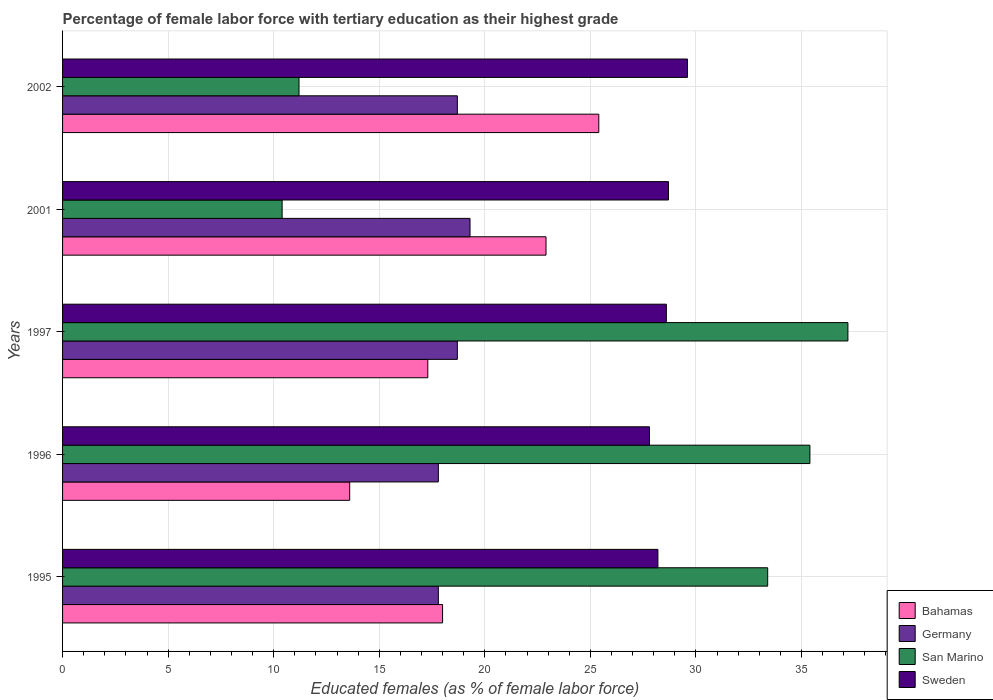How many different coloured bars are there?
Ensure brevity in your answer.  4. Are the number of bars per tick equal to the number of legend labels?
Offer a terse response. Yes. How many bars are there on the 3rd tick from the top?
Provide a short and direct response. 4. What is the percentage of female labor force with tertiary education in San Marino in 2001?
Make the answer very short. 10.4. Across all years, what is the maximum percentage of female labor force with tertiary education in Bahamas?
Provide a short and direct response. 25.4. Across all years, what is the minimum percentage of female labor force with tertiary education in Sweden?
Offer a very short reply. 27.8. In which year was the percentage of female labor force with tertiary education in San Marino minimum?
Offer a terse response. 2001. What is the total percentage of female labor force with tertiary education in Sweden in the graph?
Give a very brief answer. 142.9. What is the difference between the percentage of female labor force with tertiary education in Germany in 1995 and that in 2002?
Your answer should be compact. -0.9. What is the difference between the percentage of female labor force with tertiary education in San Marino in 1997 and the percentage of female labor force with tertiary education in Sweden in 2002?
Offer a terse response. 7.6. What is the average percentage of female labor force with tertiary education in Sweden per year?
Make the answer very short. 28.58. In the year 1997, what is the difference between the percentage of female labor force with tertiary education in Bahamas and percentage of female labor force with tertiary education in Germany?
Ensure brevity in your answer.  -1.4. What is the ratio of the percentage of female labor force with tertiary education in Sweden in 1996 to that in 2002?
Make the answer very short. 0.94. Is the difference between the percentage of female labor force with tertiary education in Bahamas in 1995 and 2002 greater than the difference between the percentage of female labor force with tertiary education in Germany in 1995 and 2002?
Provide a succinct answer. No. What is the difference between the highest and the second highest percentage of female labor force with tertiary education in Bahamas?
Offer a terse response. 2.5. In how many years, is the percentage of female labor force with tertiary education in Sweden greater than the average percentage of female labor force with tertiary education in Sweden taken over all years?
Provide a succinct answer. 3. Is it the case that in every year, the sum of the percentage of female labor force with tertiary education in Bahamas and percentage of female labor force with tertiary education in Sweden is greater than the sum of percentage of female labor force with tertiary education in San Marino and percentage of female labor force with tertiary education in Germany?
Ensure brevity in your answer.  Yes. What does the 1st bar from the top in 1996 represents?
Your response must be concise. Sweden. What does the 1st bar from the bottom in 2001 represents?
Your answer should be very brief. Bahamas. How many bars are there?
Keep it short and to the point. 20. Are all the bars in the graph horizontal?
Offer a very short reply. Yes. What is the difference between two consecutive major ticks on the X-axis?
Your answer should be compact. 5. Are the values on the major ticks of X-axis written in scientific E-notation?
Your response must be concise. No. Does the graph contain any zero values?
Offer a terse response. No. Where does the legend appear in the graph?
Your answer should be very brief. Bottom right. How are the legend labels stacked?
Your response must be concise. Vertical. What is the title of the graph?
Offer a very short reply. Percentage of female labor force with tertiary education as their highest grade. What is the label or title of the X-axis?
Keep it short and to the point. Educated females (as % of female labor force). What is the Educated females (as % of female labor force) in Germany in 1995?
Offer a terse response. 17.8. What is the Educated females (as % of female labor force) of San Marino in 1995?
Give a very brief answer. 33.4. What is the Educated females (as % of female labor force) in Sweden in 1995?
Ensure brevity in your answer.  28.2. What is the Educated females (as % of female labor force) in Bahamas in 1996?
Offer a terse response. 13.6. What is the Educated females (as % of female labor force) of Germany in 1996?
Provide a short and direct response. 17.8. What is the Educated females (as % of female labor force) of San Marino in 1996?
Your answer should be very brief. 35.4. What is the Educated females (as % of female labor force) in Sweden in 1996?
Your response must be concise. 27.8. What is the Educated females (as % of female labor force) in Bahamas in 1997?
Ensure brevity in your answer.  17.3. What is the Educated females (as % of female labor force) in Germany in 1997?
Offer a terse response. 18.7. What is the Educated females (as % of female labor force) in San Marino in 1997?
Offer a very short reply. 37.2. What is the Educated females (as % of female labor force) of Sweden in 1997?
Make the answer very short. 28.6. What is the Educated females (as % of female labor force) in Bahamas in 2001?
Your answer should be compact. 22.9. What is the Educated females (as % of female labor force) of Germany in 2001?
Give a very brief answer. 19.3. What is the Educated females (as % of female labor force) in San Marino in 2001?
Your response must be concise. 10.4. What is the Educated females (as % of female labor force) of Sweden in 2001?
Offer a very short reply. 28.7. What is the Educated females (as % of female labor force) of Bahamas in 2002?
Give a very brief answer. 25.4. What is the Educated females (as % of female labor force) in Germany in 2002?
Provide a succinct answer. 18.7. What is the Educated females (as % of female labor force) of San Marino in 2002?
Provide a short and direct response. 11.2. What is the Educated females (as % of female labor force) of Sweden in 2002?
Provide a short and direct response. 29.6. Across all years, what is the maximum Educated females (as % of female labor force) of Bahamas?
Ensure brevity in your answer.  25.4. Across all years, what is the maximum Educated females (as % of female labor force) of Germany?
Make the answer very short. 19.3. Across all years, what is the maximum Educated females (as % of female labor force) in San Marino?
Offer a very short reply. 37.2. Across all years, what is the maximum Educated females (as % of female labor force) of Sweden?
Provide a succinct answer. 29.6. Across all years, what is the minimum Educated females (as % of female labor force) in Bahamas?
Keep it short and to the point. 13.6. Across all years, what is the minimum Educated females (as % of female labor force) of Germany?
Your response must be concise. 17.8. Across all years, what is the minimum Educated females (as % of female labor force) in San Marino?
Provide a short and direct response. 10.4. Across all years, what is the minimum Educated females (as % of female labor force) of Sweden?
Ensure brevity in your answer.  27.8. What is the total Educated females (as % of female labor force) of Bahamas in the graph?
Keep it short and to the point. 97.2. What is the total Educated females (as % of female labor force) of Germany in the graph?
Provide a succinct answer. 92.3. What is the total Educated females (as % of female labor force) in San Marino in the graph?
Offer a very short reply. 127.6. What is the total Educated females (as % of female labor force) in Sweden in the graph?
Offer a terse response. 142.9. What is the difference between the Educated females (as % of female labor force) of Bahamas in 1995 and that in 1996?
Offer a terse response. 4.4. What is the difference between the Educated females (as % of female labor force) of Sweden in 1995 and that in 1996?
Your response must be concise. 0.4. What is the difference between the Educated females (as % of female labor force) in Bahamas in 1995 and that in 1997?
Your answer should be very brief. 0.7. What is the difference between the Educated females (as % of female labor force) of Germany in 1995 and that in 1997?
Provide a short and direct response. -0.9. What is the difference between the Educated females (as % of female labor force) of San Marino in 1995 and that in 1997?
Provide a succinct answer. -3.8. What is the difference between the Educated females (as % of female labor force) in Germany in 1995 and that in 2001?
Make the answer very short. -1.5. What is the difference between the Educated females (as % of female labor force) in San Marino in 1995 and that in 2001?
Provide a short and direct response. 23. What is the difference between the Educated females (as % of female labor force) in Sweden in 1995 and that in 2001?
Give a very brief answer. -0.5. What is the difference between the Educated females (as % of female labor force) of Bahamas in 1995 and that in 2002?
Your answer should be very brief. -7.4. What is the difference between the Educated females (as % of female labor force) of Germany in 1995 and that in 2002?
Your response must be concise. -0.9. What is the difference between the Educated females (as % of female labor force) in San Marino in 1995 and that in 2002?
Your answer should be very brief. 22.2. What is the difference between the Educated females (as % of female labor force) of Sweden in 1995 and that in 2002?
Provide a short and direct response. -1.4. What is the difference between the Educated females (as % of female labor force) of Germany in 1996 and that in 1997?
Keep it short and to the point. -0.9. What is the difference between the Educated females (as % of female labor force) in San Marino in 1996 and that in 1997?
Keep it short and to the point. -1.8. What is the difference between the Educated females (as % of female labor force) of Sweden in 1996 and that in 1997?
Ensure brevity in your answer.  -0.8. What is the difference between the Educated females (as % of female labor force) in Bahamas in 1996 and that in 2002?
Provide a succinct answer. -11.8. What is the difference between the Educated females (as % of female labor force) of San Marino in 1996 and that in 2002?
Make the answer very short. 24.2. What is the difference between the Educated females (as % of female labor force) in Sweden in 1996 and that in 2002?
Provide a succinct answer. -1.8. What is the difference between the Educated females (as % of female labor force) in San Marino in 1997 and that in 2001?
Offer a terse response. 26.8. What is the difference between the Educated females (as % of female labor force) of Sweden in 1997 and that in 2001?
Your response must be concise. -0.1. What is the difference between the Educated females (as % of female labor force) of Bahamas in 1997 and that in 2002?
Your answer should be compact. -8.1. What is the difference between the Educated females (as % of female labor force) of San Marino in 1997 and that in 2002?
Provide a short and direct response. 26. What is the difference between the Educated females (as % of female labor force) of Sweden in 1997 and that in 2002?
Offer a terse response. -1. What is the difference between the Educated females (as % of female labor force) in Bahamas in 2001 and that in 2002?
Make the answer very short. -2.5. What is the difference between the Educated females (as % of female labor force) in Bahamas in 1995 and the Educated females (as % of female labor force) in San Marino in 1996?
Provide a short and direct response. -17.4. What is the difference between the Educated females (as % of female labor force) of Bahamas in 1995 and the Educated females (as % of female labor force) of Sweden in 1996?
Offer a very short reply. -9.8. What is the difference between the Educated females (as % of female labor force) in Germany in 1995 and the Educated females (as % of female labor force) in San Marino in 1996?
Keep it short and to the point. -17.6. What is the difference between the Educated females (as % of female labor force) in Germany in 1995 and the Educated females (as % of female labor force) in Sweden in 1996?
Ensure brevity in your answer.  -10. What is the difference between the Educated females (as % of female labor force) in Bahamas in 1995 and the Educated females (as % of female labor force) in Germany in 1997?
Your answer should be compact. -0.7. What is the difference between the Educated females (as % of female labor force) of Bahamas in 1995 and the Educated females (as % of female labor force) of San Marino in 1997?
Your answer should be very brief. -19.2. What is the difference between the Educated females (as % of female labor force) of Bahamas in 1995 and the Educated females (as % of female labor force) of Sweden in 1997?
Make the answer very short. -10.6. What is the difference between the Educated females (as % of female labor force) in Germany in 1995 and the Educated females (as % of female labor force) in San Marino in 1997?
Provide a succinct answer. -19.4. What is the difference between the Educated females (as % of female labor force) in Germany in 1995 and the Educated females (as % of female labor force) in Sweden in 1997?
Keep it short and to the point. -10.8. What is the difference between the Educated females (as % of female labor force) of Bahamas in 1995 and the Educated females (as % of female labor force) of Sweden in 2001?
Provide a short and direct response. -10.7. What is the difference between the Educated females (as % of female labor force) of Germany in 1995 and the Educated females (as % of female labor force) of San Marino in 2001?
Ensure brevity in your answer.  7.4. What is the difference between the Educated females (as % of female labor force) of Germany in 1995 and the Educated females (as % of female labor force) of Sweden in 2001?
Offer a very short reply. -10.9. What is the difference between the Educated females (as % of female labor force) of Bahamas in 1995 and the Educated females (as % of female labor force) of Germany in 2002?
Your answer should be very brief. -0.7. What is the difference between the Educated females (as % of female labor force) of Bahamas in 1995 and the Educated females (as % of female labor force) of San Marino in 2002?
Give a very brief answer. 6.8. What is the difference between the Educated females (as % of female labor force) of Germany in 1995 and the Educated females (as % of female labor force) of San Marino in 2002?
Your response must be concise. 6.6. What is the difference between the Educated females (as % of female labor force) in Bahamas in 1996 and the Educated females (as % of female labor force) in San Marino in 1997?
Your response must be concise. -23.6. What is the difference between the Educated females (as % of female labor force) of Germany in 1996 and the Educated females (as % of female labor force) of San Marino in 1997?
Keep it short and to the point. -19.4. What is the difference between the Educated females (as % of female labor force) of Germany in 1996 and the Educated females (as % of female labor force) of Sweden in 1997?
Make the answer very short. -10.8. What is the difference between the Educated females (as % of female labor force) of Bahamas in 1996 and the Educated females (as % of female labor force) of Germany in 2001?
Your answer should be very brief. -5.7. What is the difference between the Educated females (as % of female labor force) in Bahamas in 1996 and the Educated females (as % of female labor force) in Sweden in 2001?
Provide a short and direct response. -15.1. What is the difference between the Educated females (as % of female labor force) of Germany in 1996 and the Educated females (as % of female labor force) of San Marino in 2001?
Offer a terse response. 7.4. What is the difference between the Educated females (as % of female labor force) in Germany in 1996 and the Educated females (as % of female labor force) in Sweden in 2001?
Provide a short and direct response. -10.9. What is the difference between the Educated females (as % of female labor force) in Bahamas in 1996 and the Educated females (as % of female labor force) in Sweden in 2002?
Offer a very short reply. -16. What is the difference between the Educated females (as % of female labor force) of Bahamas in 1997 and the Educated females (as % of female labor force) of Germany in 2001?
Offer a very short reply. -2. What is the difference between the Educated females (as % of female labor force) in Germany in 1997 and the Educated females (as % of female labor force) in San Marino in 2001?
Provide a short and direct response. 8.3. What is the difference between the Educated females (as % of female labor force) of Germany in 1997 and the Educated females (as % of female labor force) of Sweden in 2001?
Ensure brevity in your answer.  -10. What is the difference between the Educated females (as % of female labor force) of Bahamas in 1997 and the Educated females (as % of female labor force) of San Marino in 2002?
Keep it short and to the point. 6.1. What is the difference between the Educated females (as % of female labor force) of Bahamas in 1997 and the Educated females (as % of female labor force) of Sweden in 2002?
Provide a succinct answer. -12.3. What is the difference between the Educated females (as % of female labor force) in Germany in 1997 and the Educated females (as % of female labor force) in Sweden in 2002?
Keep it short and to the point. -10.9. What is the difference between the Educated females (as % of female labor force) in San Marino in 1997 and the Educated females (as % of female labor force) in Sweden in 2002?
Your answer should be very brief. 7.6. What is the difference between the Educated females (as % of female labor force) in Bahamas in 2001 and the Educated females (as % of female labor force) in Sweden in 2002?
Give a very brief answer. -6.7. What is the difference between the Educated females (as % of female labor force) in Germany in 2001 and the Educated females (as % of female labor force) in Sweden in 2002?
Make the answer very short. -10.3. What is the difference between the Educated females (as % of female labor force) in San Marino in 2001 and the Educated females (as % of female labor force) in Sweden in 2002?
Make the answer very short. -19.2. What is the average Educated females (as % of female labor force) in Bahamas per year?
Give a very brief answer. 19.44. What is the average Educated females (as % of female labor force) in Germany per year?
Give a very brief answer. 18.46. What is the average Educated females (as % of female labor force) of San Marino per year?
Ensure brevity in your answer.  25.52. What is the average Educated females (as % of female labor force) of Sweden per year?
Make the answer very short. 28.58. In the year 1995, what is the difference between the Educated females (as % of female labor force) of Bahamas and Educated females (as % of female labor force) of Germany?
Ensure brevity in your answer.  0.2. In the year 1995, what is the difference between the Educated females (as % of female labor force) in Bahamas and Educated females (as % of female labor force) in San Marino?
Provide a succinct answer. -15.4. In the year 1995, what is the difference between the Educated females (as % of female labor force) in Bahamas and Educated females (as % of female labor force) in Sweden?
Your answer should be very brief. -10.2. In the year 1995, what is the difference between the Educated females (as % of female labor force) of Germany and Educated females (as % of female labor force) of San Marino?
Provide a succinct answer. -15.6. In the year 1995, what is the difference between the Educated females (as % of female labor force) of San Marino and Educated females (as % of female labor force) of Sweden?
Ensure brevity in your answer.  5.2. In the year 1996, what is the difference between the Educated females (as % of female labor force) in Bahamas and Educated females (as % of female labor force) in San Marino?
Provide a succinct answer. -21.8. In the year 1996, what is the difference between the Educated females (as % of female labor force) of Germany and Educated females (as % of female labor force) of San Marino?
Give a very brief answer. -17.6. In the year 1996, what is the difference between the Educated females (as % of female labor force) in Germany and Educated females (as % of female labor force) in Sweden?
Your response must be concise. -10. In the year 1996, what is the difference between the Educated females (as % of female labor force) of San Marino and Educated females (as % of female labor force) of Sweden?
Provide a succinct answer. 7.6. In the year 1997, what is the difference between the Educated females (as % of female labor force) of Bahamas and Educated females (as % of female labor force) of San Marino?
Offer a very short reply. -19.9. In the year 1997, what is the difference between the Educated females (as % of female labor force) in Germany and Educated females (as % of female labor force) in San Marino?
Make the answer very short. -18.5. In the year 1997, what is the difference between the Educated females (as % of female labor force) of San Marino and Educated females (as % of female labor force) of Sweden?
Ensure brevity in your answer.  8.6. In the year 2001, what is the difference between the Educated females (as % of female labor force) of Bahamas and Educated females (as % of female labor force) of Germany?
Your response must be concise. 3.6. In the year 2001, what is the difference between the Educated females (as % of female labor force) of Bahamas and Educated females (as % of female labor force) of San Marino?
Your response must be concise. 12.5. In the year 2001, what is the difference between the Educated females (as % of female labor force) of Bahamas and Educated females (as % of female labor force) of Sweden?
Keep it short and to the point. -5.8. In the year 2001, what is the difference between the Educated females (as % of female labor force) of Germany and Educated females (as % of female labor force) of Sweden?
Your answer should be very brief. -9.4. In the year 2001, what is the difference between the Educated females (as % of female labor force) in San Marino and Educated females (as % of female labor force) in Sweden?
Offer a very short reply. -18.3. In the year 2002, what is the difference between the Educated females (as % of female labor force) in Bahamas and Educated females (as % of female labor force) in San Marino?
Make the answer very short. 14.2. In the year 2002, what is the difference between the Educated females (as % of female labor force) of Bahamas and Educated females (as % of female labor force) of Sweden?
Give a very brief answer. -4.2. In the year 2002, what is the difference between the Educated females (as % of female labor force) in Germany and Educated females (as % of female labor force) in Sweden?
Offer a very short reply. -10.9. In the year 2002, what is the difference between the Educated females (as % of female labor force) of San Marino and Educated females (as % of female labor force) of Sweden?
Offer a terse response. -18.4. What is the ratio of the Educated females (as % of female labor force) in Bahamas in 1995 to that in 1996?
Provide a short and direct response. 1.32. What is the ratio of the Educated females (as % of female labor force) in San Marino in 1995 to that in 1996?
Offer a very short reply. 0.94. What is the ratio of the Educated females (as % of female labor force) of Sweden in 1995 to that in 1996?
Provide a short and direct response. 1.01. What is the ratio of the Educated females (as % of female labor force) of Bahamas in 1995 to that in 1997?
Offer a very short reply. 1.04. What is the ratio of the Educated females (as % of female labor force) of Germany in 1995 to that in 1997?
Your response must be concise. 0.95. What is the ratio of the Educated females (as % of female labor force) of San Marino in 1995 to that in 1997?
Your answer should be very brief. 0.9. What is the ratio of the Educated females (as % of female labor force) in Sweden in 1995 to that in 1997?
Your response must be concise. 0.99. What is the ratio of the Educated females (as % of female labor force) of Bahamas in 1995 to that in 2001?
Your answer should be compact. 0.79. What is the ratio of the Educated females (as % of female labor force) in Germany in 1995 to that in 2001?
Make the answer very short. 0.92. What is the ratio of the Educated females (as % of female labor force) of San Marino in 1995 to that in 2001?
Your answer should be compact. 3.21. What is the ratio of the Educated females (as % of female labor force) of Sweden in 1995 to that in 2001?
Provide a short and direct response. 0.98. What is the ratio of the Educated females (as % of female labor force) in Bahamas in 1995 to that in 2002?
Make the answer very short. 0.71. What is the ratio of the Educated females (as % of female labor force) of Germany in 1995 to that in 2002?
Provide a succinct answer. 0.95. What is the ratio of the Educated females (as % of female labor force) in San Marino in 1995 to that in 2002?
Your answer should be compact. 2.98. What is the ratio of the Educated females (as % of female labor force) in Sweden in 1995 to that in 2002?
Give a very brief answer. 0.95. What is the ratio of the Educated females (as % of female labor force) of Bahamas in 1996 to that in 1997?
Provide a short and direct response. 0.79. What is the ratio of the Educated females (as % of female labor force) of Germany in 1996 to that in 1997?
Offer a very short reply. 0.95. What is the ratio of the Educated females (as % of female labor force) of San Marino in 1996 to that in 1997?
Ensure brevity in your answer.  0.95. What is the ratio of the Educated females (as % of female labor force) in Sweden in 1996 to that in 1997?
Ensure brevity in your answer.  0.97. What is the ratio of the Educated females (as % of female labor force) of Bahamas in 1996 to that in 2001?
Provide a succinct answer. 0.59. What is the ratio of the Educated females (as % of female labor force) in Germany in 1996 to that in 2001?
Offer a terse response. 0.92. What is the ratio of the Educated females (as % of female labor force) of San Marino in 1996 to that in 2001?
Keep it short and to the point. 3.4. What is the ratio of the Educated females (as % of female labor force) of Sweden in 1996 to that in 2001?
Give a very brief answer. 0.97. What is the ratio of the Educated females (as % of female labor force) in Bahamas in 1996 to that in 2002?
Offer a terse response. 0.54. What is the ratio of the Educated females (as % of female labor force) of Germany in 1996 to that in 2002?
Make the answer very short. 0.95. What is the ratio of the Educated females (as % of female labor force) in San Marino in 1996 to that in 2002?
Your answer should be very brief. 3.16. What is the ratio of the Educated females (as % of female labor force) in Sweden in 1996 to that in 2002?
Your answer should be very brief. 0.94. What is the ratio of the Educated females (as % of female labor force) in Bahamas in 1997 to that in 2001?
Your response must be concise. 0.76. What is the ratio of the Educated females (as % of female labor force) in Germany in 1997 to that in 2001?
Your answer should be compact. 0.97. What is the ratio of the Educated females (as % of female labor force) of San Marino in 1997 to that in 2001?
Make the answer very short. 3.58. What is the ratio of the Educated females (as % of female labor force) in Sweden in 1997 to that in 2001?
Provide a succinct answer. 1. What is the ratio of the Educated females (as % of female labor force) of Bahamas in 1997 to that in 2002?
Offer a very short reply. 0.68. What is the ratio of the Educated females (as % of female labor force) of Germany in 1997 to that in 2002?
Keep it short and to the point. 1. What is the ratio of the Educated females (as % of female labor force) in San Marino in 1997 to that in 2002?
Provide a short and direct response. 3.32. What is the ratio of the Educated females (as % of female labor force) of Sweden in 1997 to that in 2002?
Your answer should be very brief. 0.97. What is the ratio of the Educated females (as % of female labor force) of Bahamas in 2001 to that in 2002?
Your answer should be very brief. 0.9. What is the ratio of the Educated females (as % of female labor force) in Germany in 2001 to that in 2002?
Make the answer very short. 1.03. What is the ratio of the Educated females (as % of female labor force) in Sweden in 2001 to that in 2002?
Offer a very short reply. 0.97. What is the difference between the highest and the second highest Educated females (as % of female labor force) in San Marino?
Your answer should be very brief. 1.8. What is the difference between the highest and the lowest Educated females (as % of female labor force) of Bahamas?
Your response must be concise. 11.8. What is the difference between the highest and the lowest Educated females (as % of female labor force) of Germany?
Your answer should be compact. 1.5. What is the difference between the highest and the lowest Educated females (as % of female labor force) in San Marino?
Offer a terse response. 26.8. What is the difference between the highest and the lowest Educated females (as % of female labor force) in Sweden?
Give a very brief answer. 1.8. 